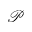<formula> <loc_0><loc_0><loc_500><loc_500>\mathcal { P }</formula> 